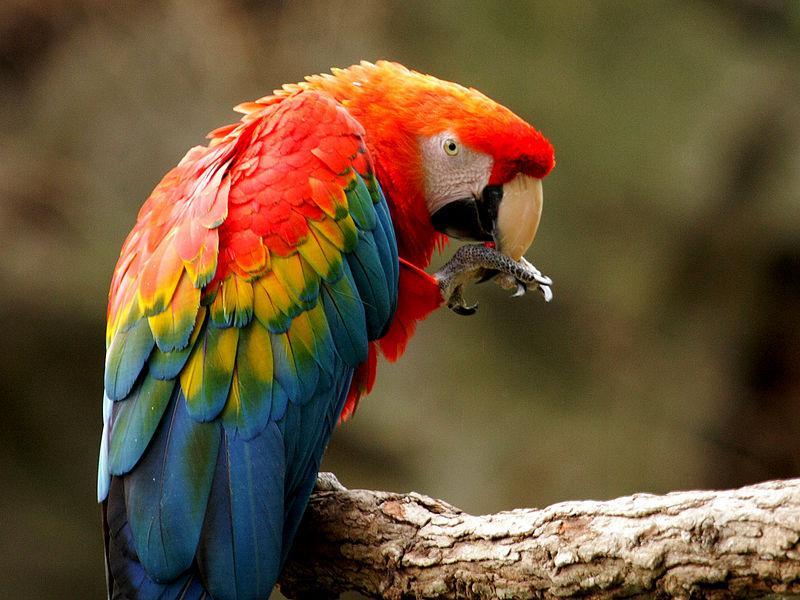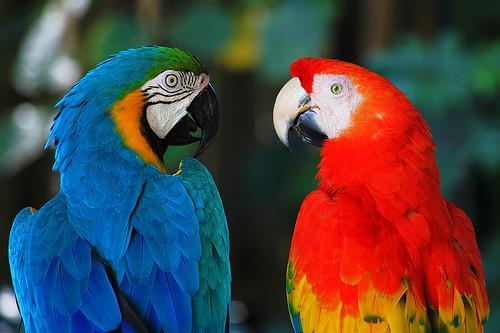The first image is the image on the left, the second image is the image on the right. Analyze the images presented: Is the assertion "There are at most three scarlet macaws.." valid? Answer yes or no. Yes. The first image is the image on the left, the second image is the image on the right. Evaluate the accuracy of this statement regarding the images: "The image on the right contains one parrot with blue wings closest to the left of the image.". Is it true? Answer yes or no. Yes. 